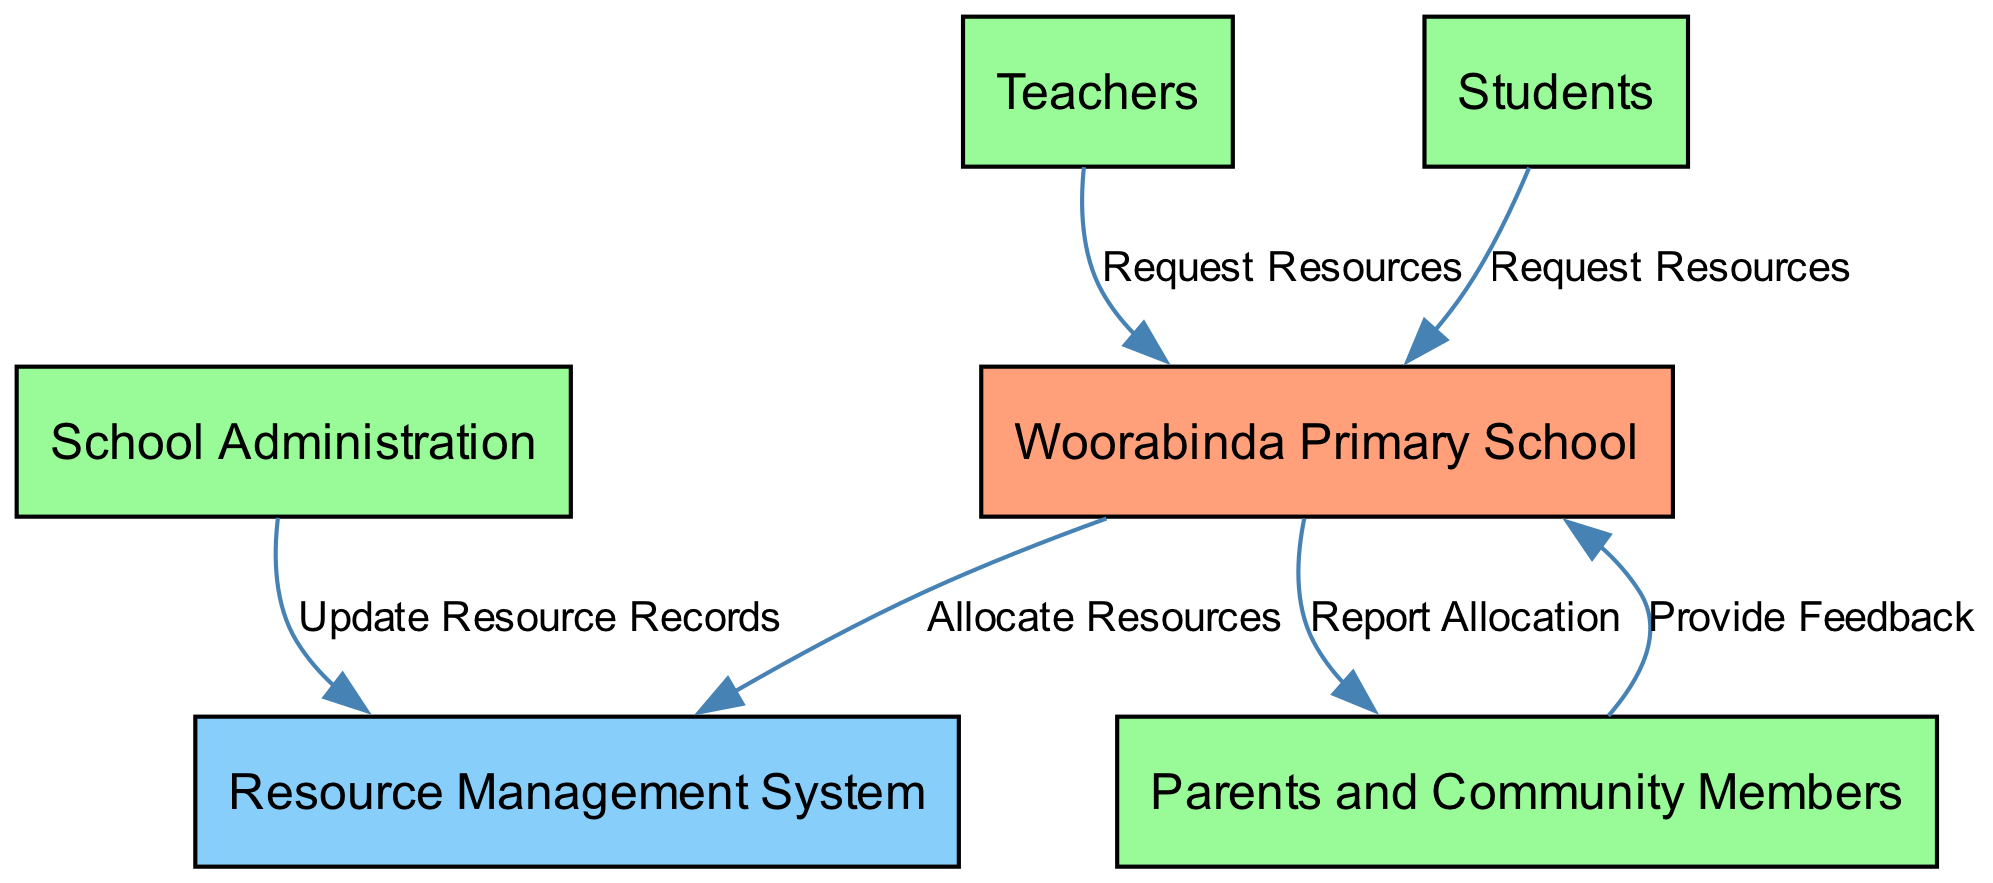What is the main entity managing resources? The main entity shown in the diagram is "Woorabinda Primary School," which is responsible for managing school resources and allocation.
Answer: Woorabinda Primary School How many external entities are in the diagram? There are four external entities depicted: Teachers, Students, School Administration, and Parents and Community Members.
Answer: Four Which external entity requests resources alongside Teachers? In addition to Teachers, Students are also depicted as external entities that send resource requests to the Woorabinda Primary School.
Answer: Students What does the Resource Management System do? The Resource Management System logs and allocates resources to approved requests made by Teachers and Students.
Answer: Allocate Resources Who provides feedback on resource allocation? Parents and Community Members are responsible for providing feedback on how resources are allocated.
Answer: Parents and Community Members What type of flow exists between School Administration and the Resource Management System? The flow is described as "Update Resource Records," indicating that School Administration updates the records within the Resource Management System.
Answer: Update Resource Records Which two entities are involved in the Request Resources process? The entities involved in the Request Resources process are Teachers and Students, both of whom send resource requests to Woorabinda Primary School.
Answer: Teachers and Students What is reported back to Parents and Community Members? The diagram indicates that Woorabinda Primary School reports resource allocation back to Parents and Community Members following their feedback.
Answer: Report Allocation What color represents the Data Store in the diagram? The Data Store, which is the Resource Management System, is represented in light blue color (#87CEFA) according to the color palette specified in the diagram.
Answer: Light blue 